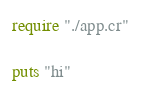<code> <loc_0><loc_0><loc_500><loc_500><_Crystal_>require "./app.cr"

puts "hi"
</code> 